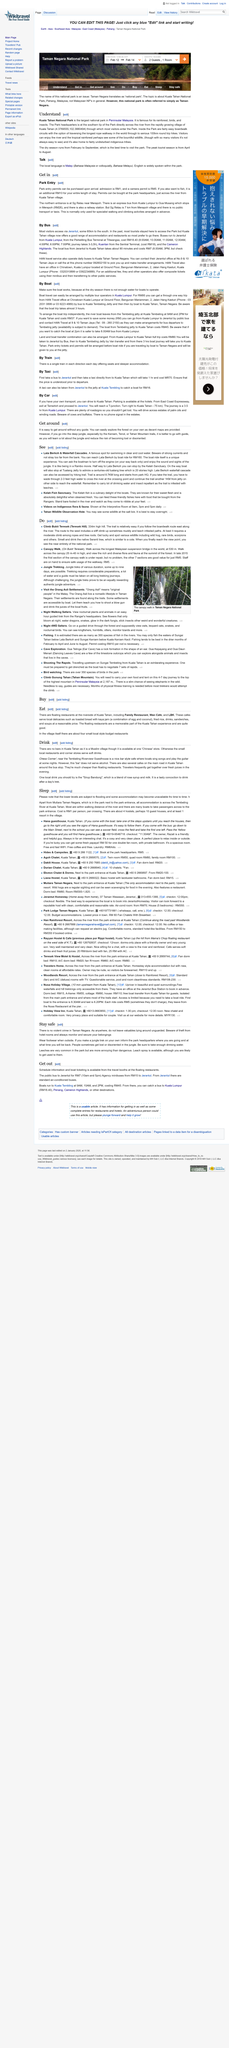Indicate a few pertinent items in this graphic. The largest national park in Peninsular Malaysia is Kuala Tahan National Park, which is known for its stunning natural beauty and diverse wildlife. The dry season in Kuala Tahan National Park lasts from February to September, during which time the park experiences minimal rainfall and pleasant weather conditions. The peak tourist season for Kuala Tahan National Park is from April to August, during which time the park experiences the highest number of visitors. 